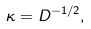<formula> <loc_0><loc_0><loc_500><loc_500>\kappa = D ^ { - 1 / 2 } ,</formula> 